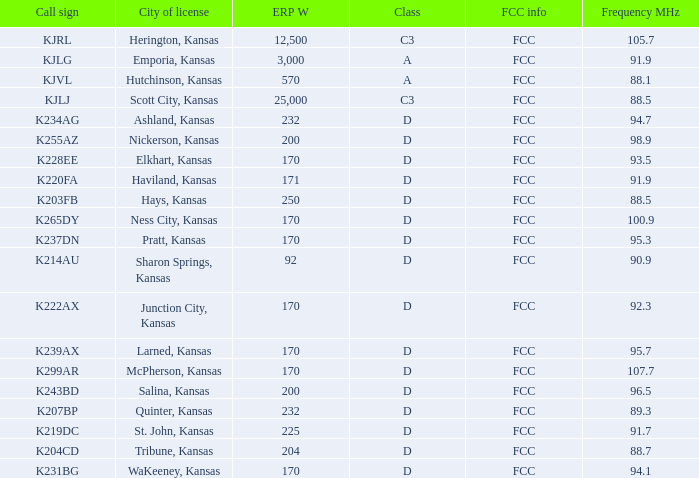Class of d, and a Frequency MHz smaller than 107.7, and a ERP W smaller than 232 has what call sign? K255AZ, K228EE, K220FA, K265DY, K237DN, K214AU, K222AX, K239AX, K243BD, K219DC, K204CD, K231BG. 